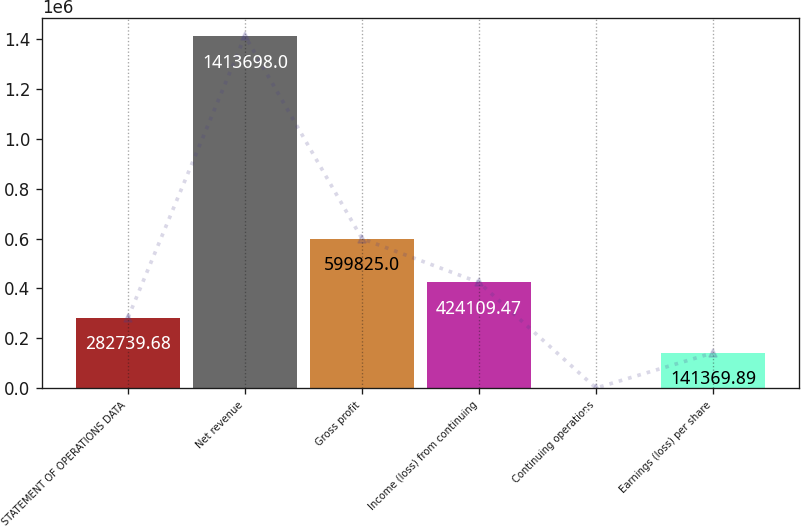Convert chart to OTSL. <chart><loc_0><loc_0><loc_500><loc_500><bar_chart><fcel>STATEMENT OF OPERATIONS DATA<fcel>Net revenue<fcel>Gross profit<fcel>Income (loss) from continuing<fcel>Continuing operations<fcel>Earnings (loss) per share<nl><fcel>282740<fcel>1.4137e+06<fcel>599825<fcel>424109<fcel>0.1<fcel>141370<nl></chart> 